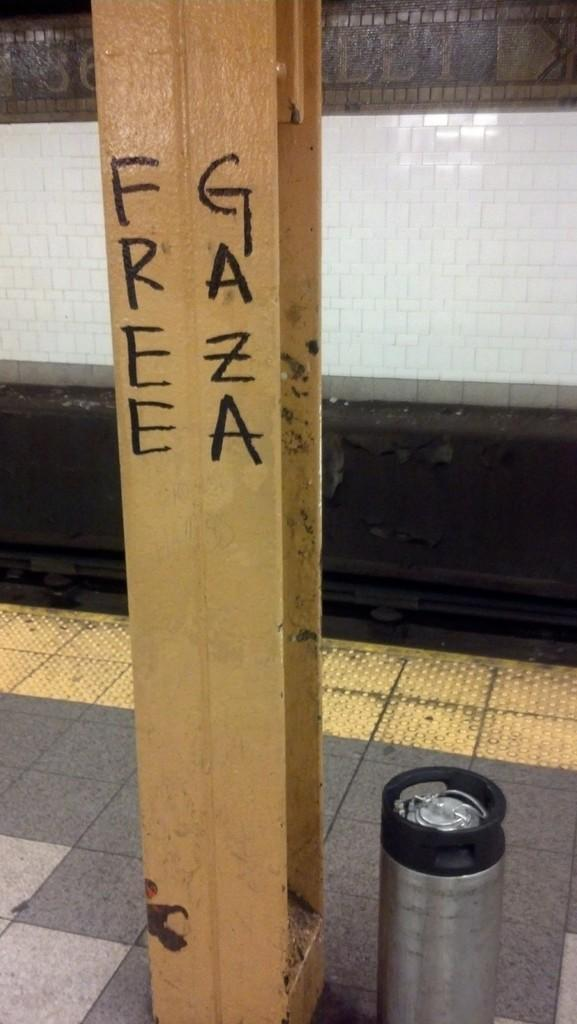<image>
Render a clear and concise summary of the photo. Free Gaza is written in black on a pole. 